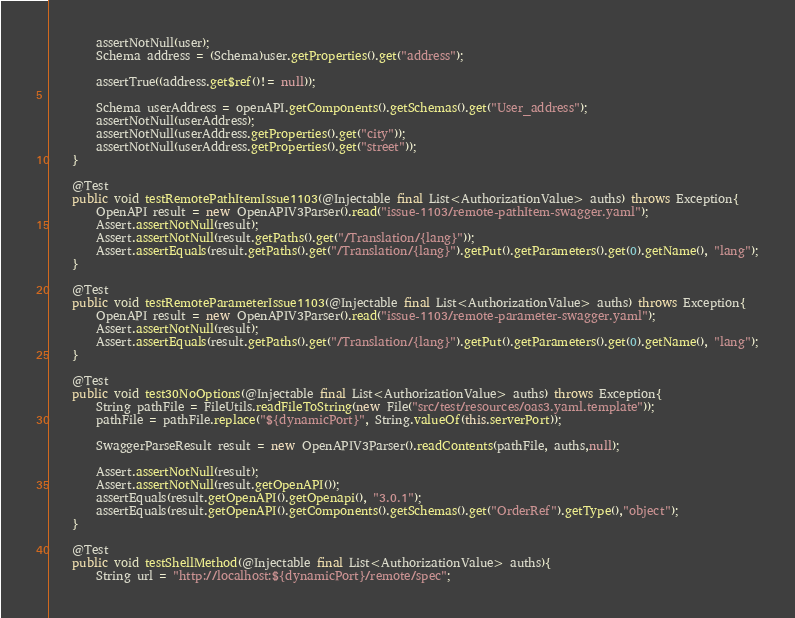<code> <loc_0><loc_0><loc_500><loc_500><_Java_>        assertNotNull(user);
        Schema address = (Schema)user.getProperties().get("address");

        assertTrue((address.get$ref()!= null));

        Schema userAddress = openAPI.getComponents().getSchemas().get("User_address");
        assertNotNull(userAddress);
        assertNotNull(userAddress.getProperties().get("city"));
        assertNotNull(userAddress.getProperties().get("street"));
    }

    @Test
    public void testRemotePathItemIssue1103(@Injectable final List<AuthorizationValue> auths) throws Exception{
        OpenAPI result = new OpenAPIV3Parser().read("issue-1103/remote-pathItem-swagger.yaml");
        Assert.assertNotNull(result);
        Assert.assertNotNull(result.getPaths().get("/Translation/{lang}"));
        Assert.assertEquals(result.getPaths().get("/Translation/{lang}").getPut().getParameters().get(0).getName(), "lang");
    }

    @Test
    public void testRemoteParameterIssue1103(@Injectable final List<AuthorizationValue> auths) throws Exception{
        OpenAPI result = new OpenAPIV3Parser().read("issue-1103/remote-parameter-swagger.yaml");
        Assert.assertNotNull(result);
        Assert.assertEquals(result.getPaths().get("/Translation/{lang}").getPut().getParameters().get(0).getName(), "lang");
    }

    @Test
    public void test30NoOptions(@Injectable final List<AuthorizationValue> auths) throws Exception{
        String pathFile = FileUtils.readFileToString(new File("src/test/resources/oas3.yaml.template"));
        pathFile = pathFile.replace("${dynamicPort}", String.valueOf(this.serverPort));

        SwaggerParseResult result = new OpenAPIV3Parser().readContents(pathFile, auths,null);

        Assert.assertNotNull(result);
        Assert.assertNotNull(result.getOpenAPI());
        assertEquals(result.getOpenAPI().getOpenapi(), "3.0.1");
        assertEquals(result.getOpenAPI().getComponents().getSchemas().get("OrderRef").getType(),"object");
    }

    @Test
    public void testShellMethod(@Injectable final List<AuthorizationValue> auths){
        String url = "http://localhost:${dynamicPort}/remote/spec";</code> 